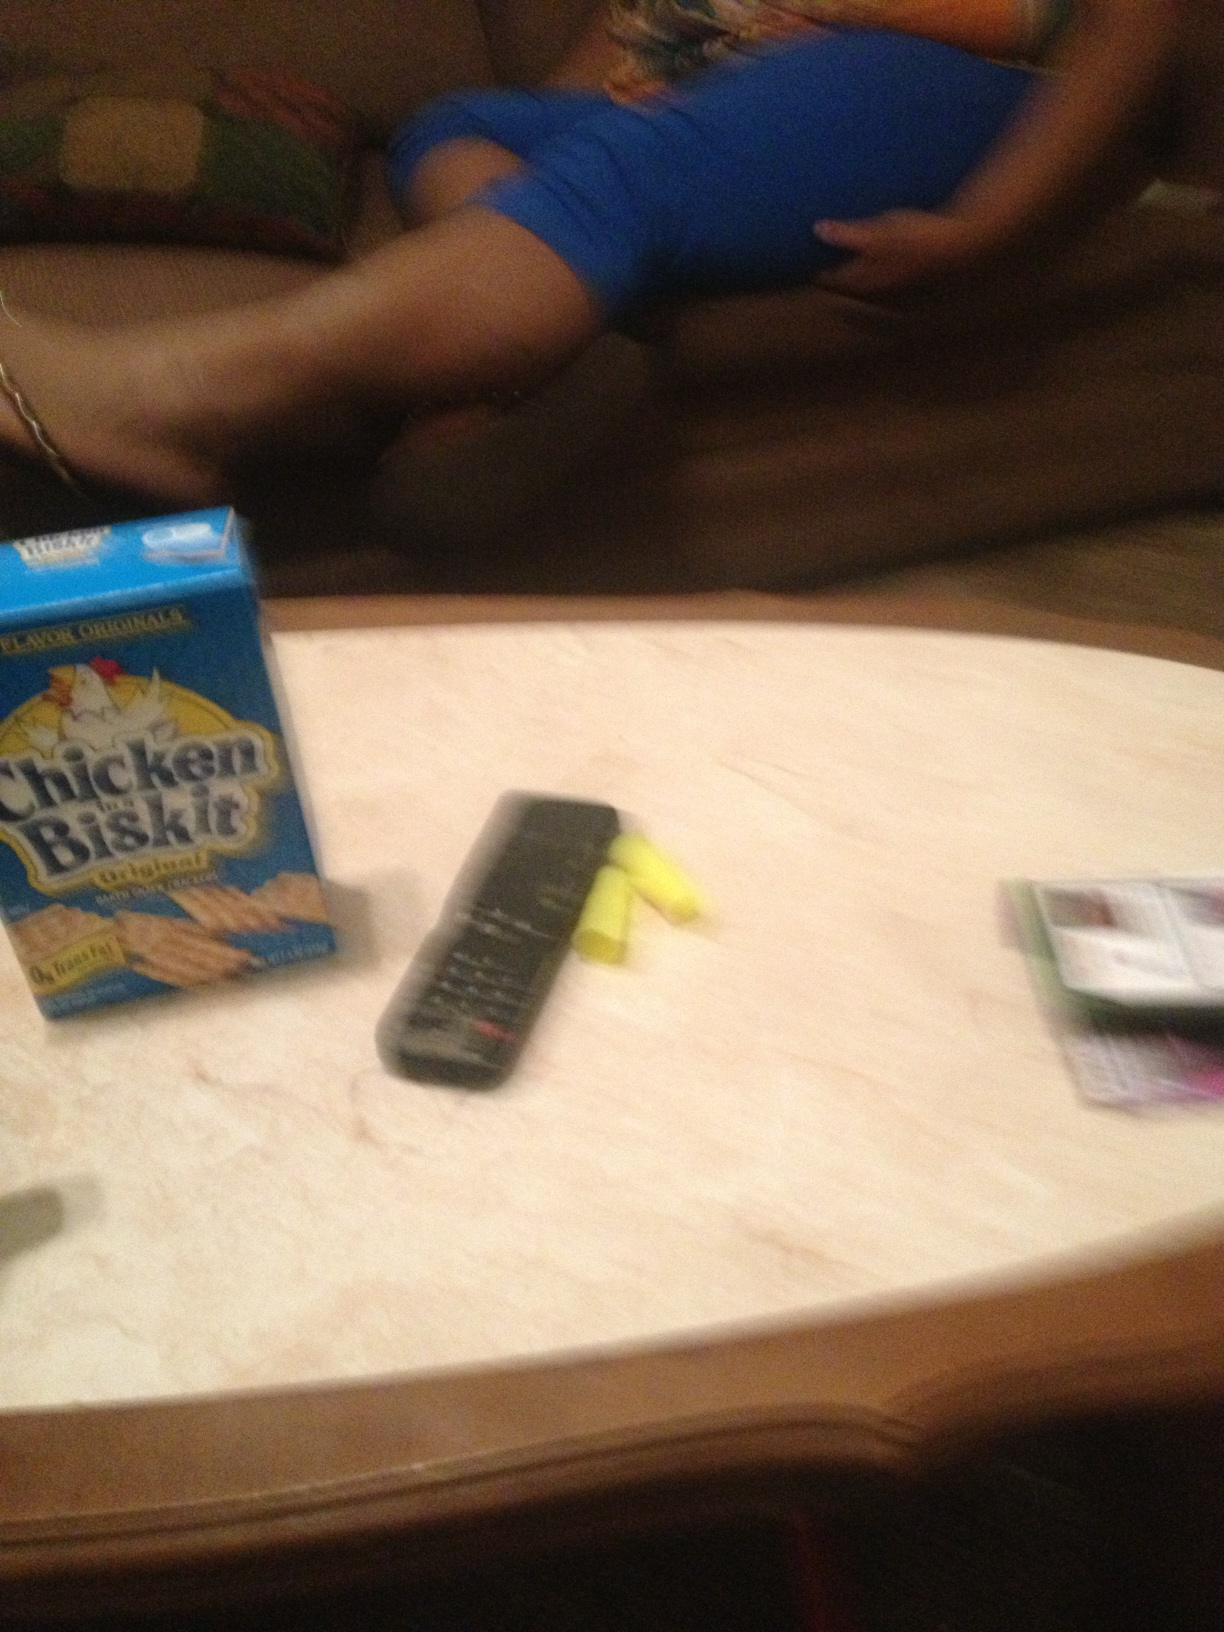What kind of activity do you think is going on here? Given the presence of snack crackers and a television remote control, it suggests that someone may have been enjoying a snack while watching TV or taking a break. The atmosphere implies leisure time and relaxation. 